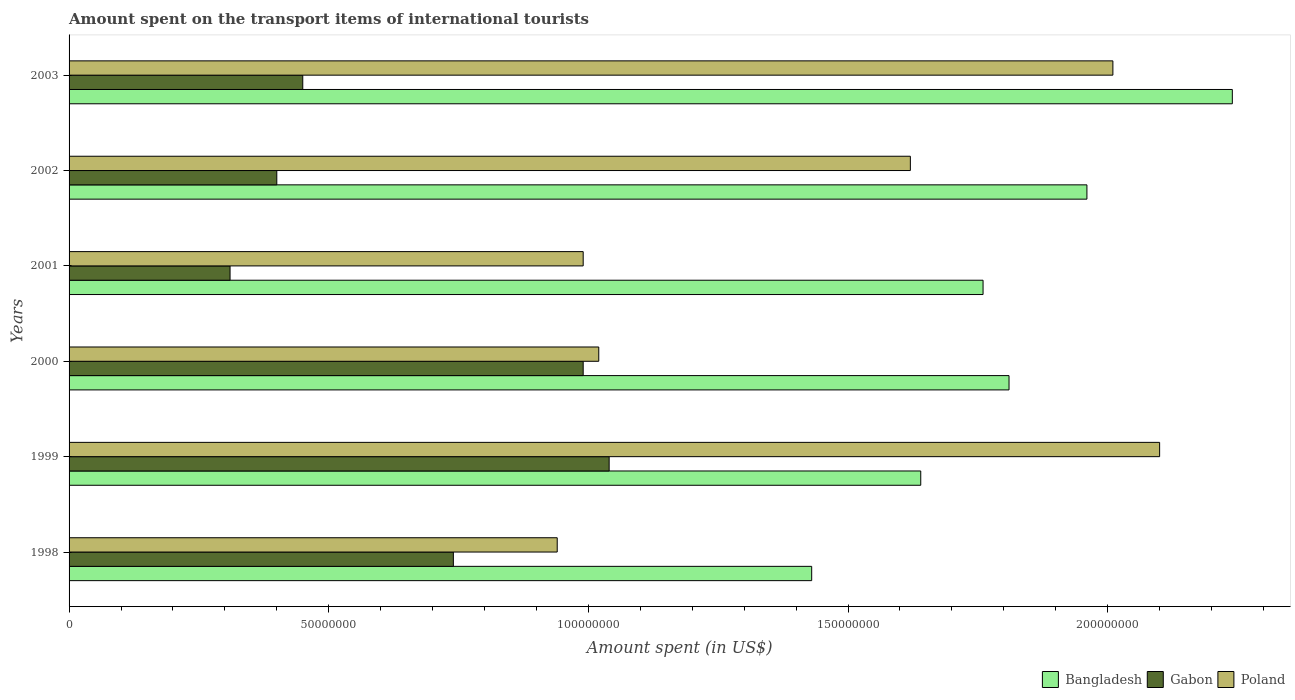How many different coloured bars are there?
Your response must be concise. 3. How many groups of bars are there?
Make the answer very short. 6. How many bars are there on the 5th tick from the top?
Ensure brevity in your answer.  3. How many bars are there on the 6th tick from the bottom?
Your answer should be very brief. 3. What is the label of the 3rd group of bars from the top?
Offer a very short reply. 2001. What is the amount spent on the transport items of international tourists in Poland in 2000?
Offer a terse response. 1.02e+08. Across all years, what is the maximum amount spent on the transport items of international tourists in Bangladesh?
Provide a succinct answer. 2.24e+08. Across all years, what is the minimum amount spent on the transport items of international tourists in Bangladesh?
Offer a terse response. 1.43e+08. In which year was the amount spent on the transport items of international tourists in Bangladesh maximum?
Provide a succinct answer. 2003. In which year was the amount spent on the transport items of international tourists in Poland minimum?
Your answer should be compact. 1998. What is the total amount spent on the transport items of international tourists in Bangladesh in the graph?
Give a very brief answer. 1.08e+09. What is the difference between the amount spent on the transport items of international tourists in Gabon in 1999 and that in 2001?
Your answer should be compact. 7.30e+07. What is the difference between the amount spent on the transport items of international tourists in Poland in 1998 and the amount spent on the transport items of international tourists in Gabon in 2002?
Provide a short and direct response. 5.40e+07. What is the average amount spent on the transport items of international tourists in Bangladesh per year?
Offer a very short reply. 1.81e+08. In the year 2001, what is the difference between the amount spent on the transport items of international tourists in Bangladesh and amount spent on the transport items of international tourists in Gabon?
Provide a short and direct response. 1.45e+08. What is the ratio of the amount spent on the transport items of international tourists in Poland in 2001 to that in 2003?
Ensure brevity in your answer.  0.49. Is the difference between the amount spent on the transport items of international tourists in Bangladesh in 1998 and 2000 greater than the difference between the amount spent on the transport items of international tourists in Gabon in 1998 and 2000?
Your response must be concise. No. What is the difference between the highest and the second highest amount spent on the transport items of international tourists in Poland?
Offer a very short reply. 9.00e+06. What is the difference between the highest and the lowest amount spent on the transport items of international tourists in Poland?
Offer a very short reply. 1.16e+08. In how many years, is the amount spent on the transport items of international tourists in Bangladesh greater than the average amount spent on the transport items of international tourists in Bangladesh taken over all years?
Make the answer very short. 3. Is the sum of the amount spent on the transport items of international tourists in Bangladesh in 1998 and 2000 greater than the maximum amount spent on the transport items of international tourists in Poland across all years?
Make the answer very short. Yes. What does the 2nd bar from the top in 2000 represents?
Offer a terse response. Gabon. What does the 2nd bar from the bottom in 1999 represents?
Keep it short and to the point. Gabon. Is it the case that in every year, the sum of the amount spent on the transport items of international tourists in Poland and amount spent on the transport items of international tourists in Gabon is greater than the amount spent on the transport items of international tourists in Bangladesh?
Ensure brevity in your answer.  No. How many bars are there?
Ensure brevity in your answer.  18. Are all the bars in the graph horizontal?
Your answer should be compact. Yes. How many years are there in the graph?
Offer a very short reply. 6. Does the graph contain grids?
Make the answer very short. No. Where does the legend appear in the graph?
Make the answer very short. Bottom right. What is the title of the graph?
Give a very brief answer. Amount spent on the transport items of international tourists. What is the label or title of the X-axis?
Keep it short and to the point. Amount spent (in US$). What is the Amount spent (in US$) of Bangladesh in 1998?
Your answer should be very brief. 1.43e+08. What is the Amount spent (in US$) of Gabon in 1998?
Your response must be concise. 7.40e+07. What is the Amount spent (in US$) in Poland in 1998?
Ensure brevity in your answer.  9.40e+07. What is the Amount spent (in US$) of Bangladesh in 1999?
Your answer should be compact. 1.64e+08. What is the Amount spent (in US$) of Gabon in 1999?
Provide a succinct answer. 1.04e+08. What is the Amount spent (in US$) of Poland in 1999?
Make the answer very short. 2.10e+08. What is the Amount spent (in US$) in Bangladesh in 2000?
Your answer should be very brief. 1.81e+08. What is the Amount spent (in US$) of Gabon in 2000?
Provide a short and direct response. 9.90e+07. What is the Amount spent (in US$) in Poland in 2000?
Offer a terse response. 1.02e+08. What is the Amount spent (in US$) of Bangladesh in 2001?
Ensure brevity in your answer.  1.76e+08. What is the Amount spent (in US$) in Gabon in 2001?
Your response must be concise. 3.10e+07. What is the Amount spent (in US$) of Poland in 2001?
Offer a terse response. 9.90e+07. What is the Amount spent (in US$) of Bangladesh in 2002?
Your answer should be compact. 1.96e+08. What is the Amount spent (in US$) of Gabon in 2002?
Give a very brief answer. 4.00e+07. What is the Amount spent (in US$) of Poland in 2002?
Provide a succinct answer. 1.62e+08. What is the Amount spent (in US$) of Bangladesh in 2003?
Provide a succinct answer. 2.24e+08. What is the Amount spent (in US$) in Gabon in 2003?
Make the answer very short. 4.50e+07. What is the Amount spent (in US$) in Poland in 2003?
Ensure brevity in your answer.  2.01e+08. Across all years, what is the maximum Amount spent (in US$) of Bangladesh?
Provide a succinct answer. 2.24e+08. Across all years, what is the maximum Amount spent (in US$) in Gabon?
Your response must be concise. 1.04e+08. Across all years, what is the maximum Amount spent (in US$) in Poland?
Offer a very short reply. 2.10e+08. Across all years, what is the minimum Amount spent (in US$) in Bangladesh?
Keep it short and to the point. 1.43e+08. Across all years, what is the minimum Amount spent (in US$) in Gabon?
Make the answer very short. 3.10e+07. Across all years, what is the minimum Amount spent (in US$) in Poland?
Ensure brevity in your answer.  9.40e+07. What is the total Amount spent (in US$) of Bangladesh in the graph?
Your answer should be very brief. 1.08e+09. What is the total Amount spent (in US$) in Gabon in the graph?
Provide a short and direct response. 3.93e+08. What is the total Amount spent (in US$) of Poland in the graph?
Offer a terse response. 8.68e+08. What is the difference between the Amount spent (in US$) in Bangladesh in 1998 and that in 1999?
Provide a succinct answer. -2.10e+07. What is the difference between the Amount spent (in US$) in Gabon in 1998 and that in 1999?
Offer a very short reply. -3.00e+07. What is the difference between the Amount spent (in US$) of Poland in 1998 and that in 1999?
Keep it short and to the point. -1.16e+08. What is the difference between the Amount spent (in US$) of Bangladesh in 1998 and that in 2000?
Provide a short and direct response. -3.80e+07. What is the difference between the Amount spent (in US$) of Gabon in 1998 and that in 2000?
Make the answer very short. -2.50e+07. What is the difference between the Amount spent (in US$) of Poland in 1998 and that in 2000?
Provide a short and direct response. -8.00e+06. What is the difference between the Amount spent (in US$) of Bangladesh in 1998 and that in 2001?
Offer a terse response. -3.30e+07. What is the difference between the Amount spent (in US$) of Gabon in 1998 and that in 2001?
Your answer should be compact. 4.30e+07. What is the difference between the Amount spent (in US$) in Poland in 1998 and that in 2001?
Ensure brevity in your answer.  -5.00e+06. What is the difference between the Amount spent (in US$) of Bangladesh in 1998 and that in 2002?
Provide a short and direct response. -5.30e+07. What is the difference between the Amount spent (in US$) in Gabon in 1998 and that in 2002?
Your answer should be compact. 3.40e+07. What is the difference between the Amount spent (in US$) of Poland in 1998 and that in 2002?
Make the answer very short. -6.80e+07. What is the difference between the Amount spent (in US$) of Bangladesh in 1998 and that in 2003?
Your response must be concise. -8.10e+07. What is the difference between the Amount spent (in US$) of Gabon in 1998 and that in 2003?
Give a very brief answer. 2.90e+07. What is the difference between the Amount spent (in US$) of Poland in 1998 and that in 2003?
Make the answer very short. -1.07e+08. What is the difference between the Amount spent (in US$) of Bangladesh in 1999 and that in 2000?
Your answer should be very brief. -1.70e+07. What is the difference between the Amount spent (in US$) of Poland in 1999 and that in 2000?
Offer a terse response. 1.08e+08. What is the difference between the Amount spent (in US$) in Bangladesh in 1999 and that in 2001?
Your response must be concise. -1.20e+07. What is the difference between the Amount spent (in US$) in Gabon in 1999 and that in 2001?
Your response must be concise. 7.30e+07. What is the difference between the Amount spent (in US$) of Poland in 1999 and that in 2001?
Your response must be concise. 1.11e+08. What is the difference between the Amount spent (in US$) in Bangladesh in 1999 and that in 2002?
Provide a short and direct response. -3.20e+07. What is the difference between the Amount spent (in US$) in Gabon in 1999 and that in 2002?
Provide a succinct answer. 6.40e+07. What is the difference between the Amount spent (in US$) in Poland in 1999 and that in 2002?
Provide a succinct answer. 4.80e+07. What is the difference between the Amount spent (in US$) of Bangladesh in 1999 and that in 2003?
Ensure brevity in your answer.  -6.00e+07. What is the difference between the Amount spent (in US$) in Gabon in 1999 and that in 2003?
Your answer should be very brief. 5.90e+07. What is the difference between the Amount spent (in US$) in Poland in 1999 and that in 2003?
Give a very brief answer. 9.00e+06. What is the difference between the Amount spent (in US$) of Bangladesh in 2000 and that in 2001?
Keep it short and to the point. 5.00e+06. What is the difference between the Amount spent (in US$) in Gabon in 2000 and that in 2001?
Keep it short and to the point. 6.80e+07. What is the difference between the Amount spent (in US$) in Poland in 2000 and that in 2001?
Offer a very short reply. 3.00e+06. What is the difference between the Amount spent (in US$) of Bangladesh in 2000 and that in 2002?
Your response must be concise. -1.50e+07. What is the difference between the Amount spent (in US$) in Gabon in 2000 and that in 2002?
Your response must be concise. 5.90e+07. What is the difference between the Amount spent (in US$) in Poland in 2000 and that in 2002?
Keep it short and to the point. -6.00e+07. What is the difference between the Amount spent (in US$) of Bangladesh in 2000 and that in 2003?
Make the answer very short. -4.30e+07. What is the difference between the Amount spent (in US$) of Gabon in 2000 and that in 2003?
Your answer should be compact. 5.40e+07. What is the difference between the Amount spent (in US$) in Poland in 2000 and that in 2003?
Your answer should be very brief. -9.90e+07. What is the difference between the Amount spent (in US$) in Bangladesh in 2001 and that in 2002?
Make the answer very short. -2.00e+07. What is the difference between the Amount spent (in US$) in Gabon in 2001 and that in 2002?
Provide a succinct answer. -9.00e+06. What is the difference between the Amount spent (in US$) of Poland in 2001 and that in 2002?
Provide a succinct answer. -6.30e+07. What is the difference between the Amount spent (in US$) in Bangladesh in 2001 and that in 2003?
Ensure brevity in your answer.  -4.80e+07. What is the difference between the Amount spent (in US$) of Gabon in 2001 and that in 2003?
Provide a short and direct response. -1.40e+07. What is the difference between the Amount spent (in US$) of Poland in 2001 and that in 2003?
Give a very brief answer. -1.02e+08. What is the difference between the Amount spent (in US$) of Bangladesh in 2002 and that in 2003?
Give a very brief answer. -2.80e+07. What is the difference between the Amount spent (in US$) in Gabon in 2002 and that in 2003?
Keep it short and to the point. -5.00e+06. What is the difference between the Amount spent (in US$) in Poland in 2002 and that in 2003?
Your response must be concise. -3.90e+07. What is the difference between the Amount spent (in US$) in Bangladesh in 1998 and the Amount spent (in US$) in Gabon in 1999?
Make the answer very short. 3.90e+07. What is the difference between the Amount spent (in US$) of Bangladesh in 1998 and the Amount spent (in US$) of Poland in 1999?
Provide a succinct answer. -6.70e+07. What is the difference between the Amount spent (in US$) of Gabon in 1998 and the Amount spent (in US$) of Poland in 1999?
Ensure brevity in your answer.  -1.36e+08. What is the difference between the Amount spent (in US$) in Bangladesh in 1998 and the Amount spent (in US$) in Gabon in 2000?
Keep it short and to the point. 4.40e+07. What is the difference between the Amount spent (in US$) of Bangladesh in 1998 and the Amount spent (in US$) of Poland in 2000?
Your response must be concise. 4.10e+07. What is the difference between the Amount spent (in US$) in Gabon in 1998 and the Amount spent (in US$) in Poland in 2000?
Make the answer very short. -2.80e+07. What is the difference between the Amount spent (in US$) in Bangladesh in 1998 and the Amount spent (in US$) in Gabon in 2001?
Ensure brevity in your answer.  1.12e+08. What is the difference between the Amount spent (in US$) of Bangladesh in 1998 and the Amount spent (in US$) of Poland in 2001?
Offer a very short reply. 4.40e+07. What is the difference between the Amount spent (in US$) in Gabon in 1998 and the Amount spent (in US$) in Poland in 2001?
Your answer should be compact. -2.50e+07. What is the difference between the Amount spent (in US$) in Bangladesh in 1998 and the Amount spent (in US$) in Gabon in 2002?
Give a very brief answer. 1.03e+08. What is the difference between the Amount spent (in US$) of Bangladesh in 1998 and the Amount spent (in US$) of Poland in 2002?
Your answer should be very brief. -1.90e+07. What is the difference between the Amount spent (in US$) in Gabon in 1998 and the Amount spent (in US$) in Poland in 2002?
Provide a succinct answer. -8.80e+07. What is the difference between the Amount spent (in US$) of Bangladesh in 1998 and the Amount spent (in US$) of Gabon in 2003?
Offer a terse response. 9.80e+07. What is the difference between the Amount spent (in US$) in Bangladesh in 1998 and the Amount spent (in US$) in Poland in 2003?
Your answer should be very brief. -5.80e+07. What is the difference between the Amount spent (in US$) of Gabon in 1998 and the Amount spent (in US$) of Poland in 2003?
Your response must be concise. -1.27e+08. What is the difference between the Amount spent (in US$) in Bangladesh in 1999 and the Amount spent (in US$) in Gabon in 2000?
Make the answer very short. 6.50e+07. What is the difference between the Amount spent (in US$) in Bangladesh in 1999 and the Amount spent (in US$) in Poland in 2000?
Give a very brief answer. 6.20e+07. What is the difference between the Amount spent (in US$) of Bangladesh in 1999 and the Amount spent (in US$) of Gabon in 2001?
Make the answer very short. 1.33e+08. What is the difference between the Amount spent (in US$) in Bangladesh in 1999 and the Amount spent (in US$) in Poland in 2001?
Make the answer very short. 6.50e+07. What is the difference between the Amount spent (in US$) in Bangladesh in 1999 and the Amount spent (in US$) in Gabon in 2002?
Offer a terse response. 1.24e+08. What is the difference between the Amount spent (in US$) of Bangladesh in 1999 and the Amount spent (in US$) of Poland in 2002?
Ensure brevity in your answer.  2.00e+06. What is the difference between the Amount spent (in US$) in Gabon in 1999 and the Amount spent (in US$) in Poland in 2002?
Ensure brevity in your answer.  -5.80e+07. What is the difference between the Amount spent (in US$) of Bangladesh in 1999 and the Amount spent (in US$) of Gabon in 2003?
Offer a terse response. 1.19e+08. What is the difference between the Amount spent (in US$) in Bangladesh in 1999 and the Amount spent (in US$) in Poland in 2003?
Offer a very short reply. -3.70e+07. What is the difference between the Amount spent (in US$) of Gabon in 1999 and the Amount spent (in US$) of Poland in 2003?
Offer a terse response. -9.70e+07. What is the difference between the Amount spent (in US$) of Bangladesh in 2000 and the Amount spent (in US$) of Gabon in 2001?
Give a very brief answer. 1.50e+08. What is the difference between the Amount spent (in US$) of Bangladesh in 2000 and the Amount spent (in US$) of Poland in 2001?
Offer a terse response. 8.20e+07. What is the difference between the Amount spent (in US$) of Gabon in 2000 and the Amount spent (in US$) of Poland in 2001?
Offer a terse response. 0. What is the difference between the Amount spent (in US$) of Bangladesh in 2000 and the Amount spent (in US$) of Gabon in 2002?
Offer a very short reply. 1.41e+08. What is the difference between the Amount spent (in US$) in Bangladesh in 2000 and the Amount spent (in US$) in Poland in 2002?
Make the answer very short. 1.90e+07. What is the difference between the Amount spent (in US$) of Gabon in 2000 and the Amount spent (in US$) of Poland in 2002?
Offer a terse response. -6.30e+07. What is the difference between the Amount spent (in US$) of Bangladesh in 2000 and the Amount spent (in US$) of Gabon in 2003?
Offer a very short reply. 1.36e+08. What is the difference between the Amount spent (in US$) of Bangladesh in 2000 and the Amount spent (in US$) of Poland in 2003?
Keep it short and to the point. -2.00e+07. What is the difference between the Amount spent (in US$) in Gabon in 2000 and the Amount spent (in US$) in Poland in 2003?
Provide a short and direct response. -1.02e+08. What is the difference between the Amount spent (in US$) of Bangladesh in 2001 and the Amount spent (in US$) of Gabon in 2002?
Give a very brief answer. 1.36e+08. What is the difference between the Amount spent (in US$) of Bangladesh in 2001 and the Amount spent (in US$) of Poland in 2002?
Give a very brief answer. 1.40e+07. What is the difference between the Amount spent (in US$) in Gabon in 2001 and the Amount spent (in US$) in Poland in 2002?
Give a very brief answer. -1.31e+08. What is the difference between the Amount spent (in US$) of Bangladesh in 2001 and the Amount spent (in US$) of Gabon in 2003?
Offer a very short reply. 1.31e+08. What is the difference between the Amount spent (in US$) of Bangladesh in 2001 and the Amount spent (in US$) of Poland in 2003?
Offer a terse response. -2.50e+07. What is the difference between the Amount spent (in US$) of Gabon in 2001 and the Amount spent (in US$) of Poland in 2003?
Ensure brevity in your answer.  -1.70e+08. What is the difference between the Amount spent (in US$) in Bangladesh in 2002 and the Amount spent (in US$) in Gabon in 2003?
Provide a short and direct response. 1.51e+08. What is the difference between the Amount spent (in US$) in Bangladesh in 2002 and the Amount spent (in US$) in Poland in 2003?
Give a very brief answer. -5.00e+06. What is the difference between the Amount spent (in US$) of Gabon in 2002 and the Amount spent (in US$) of Poland in 2003?
Your answer should be very brief. -1.61e+08. What is the average Amount spent (in US$) in Bangladesh per year?
Provide a short and direct response. 1.81e+08. What is the average Amount spent (in US$) in Gabon per year?
Offer a very short reply. 6.55e+07. What is the average Amount spent (in US$) in Poland per year?
Provide a short and direct response. 1.45e+08. In the year 1998, what is the difference between the Amount spent (in US$) of Bangladesh and Amount spent (in US$) of Gabon?
Keep it short and to the point. 6.90e+07. In the year 1998, what is the difference between the Amount spent (in US$) of Bangladesh and Amount spent (in US$) of Poland?
Your answer should be compact. 4.90e+07. In the year 1998, what is the difference between the Amount spent (in US$) of Gabon and Amount spent (in US$) of Poland?
Your answer should be compact. -2.00e+07. In the year 1999, what is the difference between the Amount spent (in US$) of Bangladesh and Amount spent (in US$) of Gabon?
Make the answer very short. 6.00e+07. In the year 1999, what is the difference between the Amount spent (in US$) in Bangladesh and Amount spent (in US$) in Poland?
Your answer should be compact. -4.60e+07. In the year 1999, what is the difference between the Amount spent (in US$) of Gabon and Amount spent (in US$) of Poland?
Your answer should be very brief. -1.06e+08. In the year 2000, what is the difference between the Amount spent (in US$) in Bangladesh and Amount spent (in US$) in Gabon?
Ensure brevity in your answer.  8.20e+07. In the year 2000, what is the difference between the Amount spent (in US$) of Bangladesh and Amount spent (in US$) of Poland?
Your response must be concise. 7.90e+07. In the year 2001, what is the difference between the Amount spent (in US$) of Bangladesh and Amount spent (in US$) of Gabon?
Offer a terse response. 1.45e+08. In the year 2001, what is the difference between the Amount spent (in US$) in Bangladesh and Amount spent (in US$) in Poland?
Provide a succinct answer. 7.70e+07. In the year 2001, what is the difference between the Amount spent (in US$) of Gabon and Amount spent (in US$) of Poland?
Give a very brief answer. -6.80e+07. In the year 2002, what is the difference between the Amount spent (in US$) in Bangladesh and Amount spent (in US$) in Gabon?
Provide a short and direct response. 1.56e+08. In the year 2002, what is the difference between the Amount spent (in US$) of Bangladesh and Amount spent (in US$) of Poland?
Provide a succinct answer. 3.40e+07. In the year 2002, what is the difference between the Amount spent (in US$) of Gabon and Amount spent (in US$) of Poland?
Provide a short and direct response. -1.22e+08. In the year 2003, what is the difference between the Amount spent (in US$) of Bangladesh and Amount spent (in US$) of Gabon?
Keep it short and to the point. 1.79e+08. In the year 2003, what is the difference between the Amount spent (in US$) in Bangladesh and Amount spent (in US$) in Poland?
Provide a short and direct response. 2.30e+07. In the year 2003, what is the difference between the Amount spent (in US$) in Gabon and Amount spent (in US$) in Poland?
Give a very brief answer. -1.56e+08. What is the ratio of the Amount spent (in US$) of Bangladesh in 1998 to that in 1999?
Ensure brevity in your answer.  0.87. What is the ratio of the Amount spent (in US$) of Gabon in 1998 to that in 1999?
Your answer should be compact. 0.71. What is the ratio of the Amount spent (in US$) of Poland in 1998 to that in 1999?
Give a very brief answer. 0.45. What is the ratio of the Amount spent (in US$) of Bangladesh in 1998 to that in 2000?
Ensure brevity in your answer.  0.79. What is the ratio of the Amount spent (in US$) of Gabon in 1998 to that in 2000?
Keep it short and to the point. 0.75. What is the ratio of the Amount spent (in US$) of Poland in 1998 to that in 2000?
Offer a very short reply. 0.92. What is the ratio of the Amount spent (in US$) of Bangladesh in 1998 to that in 2001?
Give a very brief answer. 0.81. What is the ratio of the Amount spent (in US$) in Gabon in 1998 to that in 2001?
Your response must be concise. 2.39. What is the ratio of the Amount spent (in US$) of Poland in 1998 to that in 2001?
Keep it short and to the point. 0.95. What is the ratio of the Amount spent (in US$) in Bangladesh in 1998 to that in 2002?
Keep it short and to the point. 0.73. What is the ratio of the Amount spent (in US$) in Gabon in 1998 to that in 2002?
Your response must be concise. 1.85. What is the ratio of the Amount spent (in US$) in Poland in 1998 to that in 2002?
Offer a terse response. 0.58. What is the ratio of the Amount spent (in US$) in Bangladesh in 1998 to that in 2003?
Provide a succinct answer. 0.64. What is the ratio of the Amount spent (in US$) in Gabon in 1998 to that in 2003?
Offer a terse response. 1.64. What is the ratio of the Amount spent (in US$) in Poland in 1998 to that in 2003?
Your answer should be very brief. 0.47. What is the ratio of the Amount spent (in US$) in Bangladesh in 1999 to that in 2000?
Ensure brevity in your answer.  0.91. What is the ratio of the Amount spent (in US$) of Gabon in 1999 to that in 2000?
Your answer should be very brief. 1.05. What is the ratio of the Amount spent (in US$) of Poland in 1999 to that in 2000?
Keep it short and to the point. 2.06. What is the ratio of the Amount spent (in US$) in Bangladesh in 1999 to that in 2001?
Provide a succinct answer. 0.93. What is the ratio of the Amount spent (in US$) in Gabon in 1999 to that in 2001?
Ensure brevity in your answer.  3.35. What is the ratio of the Amount spent (in US$) in Poland in 1999 to that in 2001?
Provide a succinct answer. 2.12. What is the ratio of the Amount spent (in US$) in Bangladesh in 1999 to that in 2002?
Offer a very short reply. 0.84. What is the ratio of the Amount spent (in US$) of Poland in 1999 to that in 2002?
Provide a succinct answer. 1.3. What is the ratio of the Amount spent (in US$) of Bangladesh in 1999 to that in 2003?
Provide a short and direct response. 0.73. What is the ratio of the Amount spent (in US$) of Gabon in 1999 to that in 2003?
Make the answer very short. 2.31. What is the ratio of the Amount spent (in US$) of Poland in 1999 to that in 2003?
Offer a terse response. 1.04. What is the ratio of the Amount spent (in US$) in Bangladesh in 2000 to that in 2001?
Your answer should be very brief. 1.03. What is the ratio of the Amount spent (in US$) in Gabon in 2000 to that in 2001?
Provide a short and direct response. 3.19. What is the ratio of the Amount spent (in US$) of Poland in 2000 to that in 2001?
Keep it short and to the point. 1.03. What is the ratio of the Amount spent (in US$) in Bangladesh in 2000 to that in 2002?
Provide a short and direct response. 0.92. What is the ratio of the Amount spent (in US$) in Gabon in 2000 to that in 2002?
Offer a very short reply. 2.48. What is the ratio of the Amount spent (in US$) of Poland in 2000 to that in 2002?
Give a very brief answer. 0.63. What is the ratio of the Amount spent (in US$) of Bangladesh in 2000 to that in 2003?
Offer a very short reply. 0.81. What is the ratio of the Amount spent (in US$) in Poland in 2000 to that in 2003?
Your answer should be very brief. 0.51. What is the ratio of the Amount spent (in US$) of Bangladesh in 2001 to that in 2002?
Give a very brief answer. 0.9. What is the ratio of the Amount spent (in US$) in Gabon in 2001 to that in 2002?
Your answer should be very brief. 0.78. What is the ratio of the Amount spent (in US$) of Poland in 2001 to that in 2002?
Offer a terse response. 0.61. What is the ratio of the Amount spent (in US$) of Bangladesh in 2001 to that in 2003?
Keep it short and to the point. 0.79. What is the ratio of the Amount spent (in US$) of Gabon in 2001 to that in 2003?
Make the answer very short. 0.69. What is the ratio of the Amount spent (in US$) in Poland in 2001 to that in 2003?
Keep it short and to the point. 0.49. What is the ratio of the Amount spent (in US$) in Gabon in 2002 to that in 2003?
Make the answer very short. 0.89. What is the ratio of the Amount spent (in US$) in Poland in 2002 to that in 2003?
Keep it short and to the point. 0.81. What is the difference between the highest and the second highest Amount spent (in US$) in Bangladesh?
Provide a short and direct response. 2.80e+07. What is the difference between the highest and the second highest Amount spent (in US$) of Gabon?
Make the answer very short. 5.00e+06. What is the difference between the highest and the second highest Amount spent (in US$) of Poland?
Make the answer very short. 9.00e+06. What is the difference between the highest and the lowest Amount spent (in US$) of Bangladesh?
Your answer should be compact. 8.10e+07. What is the difference between the highest and the lowest Amount spent (in US$) in Gabon?
Keep it short and to the point. 7.30e+07. What is the difference between the highest and the lowest Amount spent (in US$) in Poland?
Make the answer very short. 1.16e+08. 